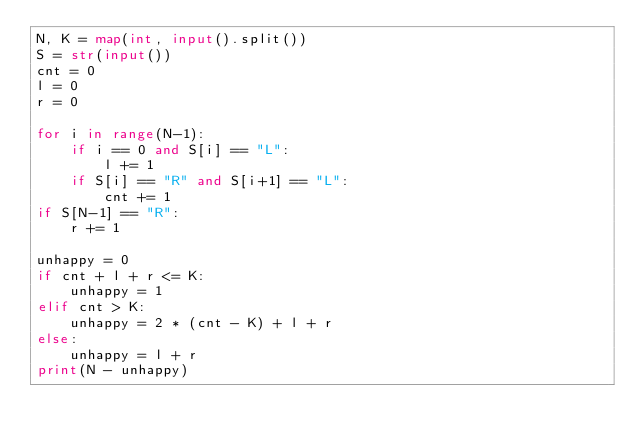Convert code to text. <code><loc_0><loc_0><loc_500><loc_500><_Python_>N, K = map(int, input().split())
S = str(input())
cnt = 0
l = 0
r = 0

for i in range(N-1):
    if i == 0 and S[i] == "L":
        l += 1
    if S[i] == "R" and S[i+1] == "L":
        cnt += 1
if S[N-1] == "R":
    r += 1

unhappy = 0
if cnt + l + r <= K:
    unhappy = 1
elif cnt > K:
    unhappy = 2 * (cnt - K) + l + r
else:
    unhappy = l + r
print(N - unhappy)

</code> 